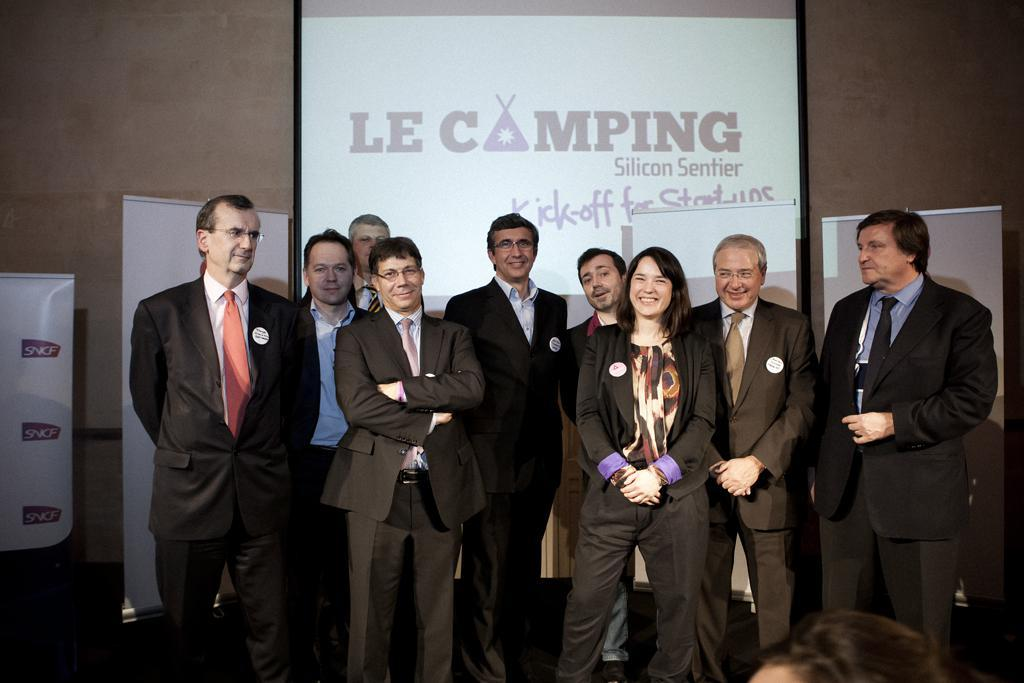How many people can be seen in the image? There are many people standing in the image. What are the people wearing? The people are wearing clothes and ties. What is the purpose of the projected screen in the image? The projected screen is likely used for displaying information or presentations. What other visual aids are present in the image? There are many posters and a whiteboard in the image. Can you hear the rhythm of the geese in the image? There are no geese present in the image, so it is not possible to hear their rhythm. 